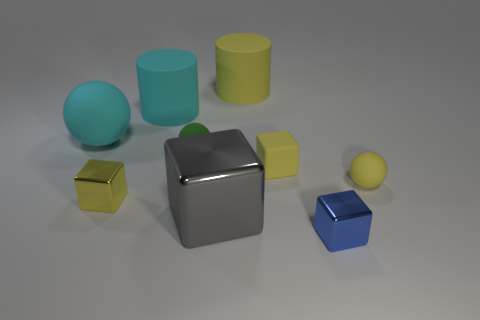There is a small block left of the big rubber cylinder on the left side of the tiny ball to the left of the small yellow sphere; what is its color?
Your answer should be very brief. Yellow. Is the color of the big sphere the same as the large metal cube?
Ensure brevity in your answer.  No. What number of large things are behind the yellow shiny thing and right of the green matte ball?
Give a very brief answer. 1. How many metal objects are either gray objects or blue cylinders?
Make the answer very short. 1. What is the material of the large object that is in front of the yellow block to the left of the cyan cylinder?
Your response must be concise. Metal. What is the shape of the matte thing that is the same color as the large ball?
Offer a very short reply. Cylinder. There is a yellow matte object that is the same size as the cyan cylinder; what is its shape?
Your answer should be very brief. Cylinder. Is the number of tiny yellow spheres less than the number of small purple balls?
Your answer should be very brief. No. There is a tiny shiny thing that is right of the rubber cube; is there a metal thing left of it?
Ensure brevity in your answer.  Yes. There is a yellow object that is made of the same material as the gray block; what is its shape?
Ensure brevity in your answer.  Cube. 